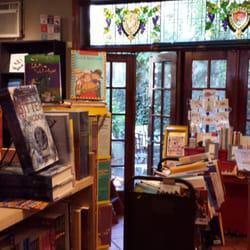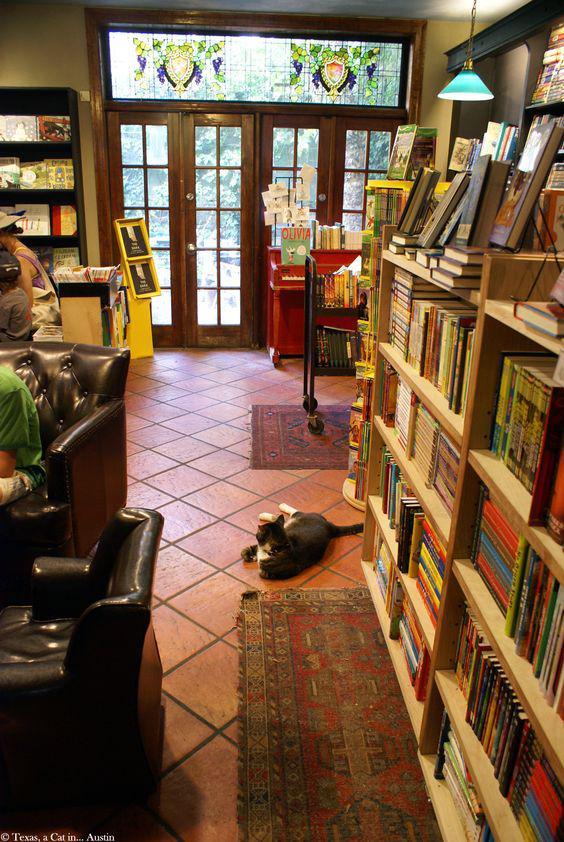The first image is the image on the left, the second image is the image on the right. Considering the images on both sides, is "wooden french doors are open and visible from the inside of the store" valid? Answer yes or no. Yes. The first image is the image on the left, the second image is the image on the right. For the images shown, is this caption "There is a stained glass window visible over the doorway." true? Answer yes or no. Yes. 